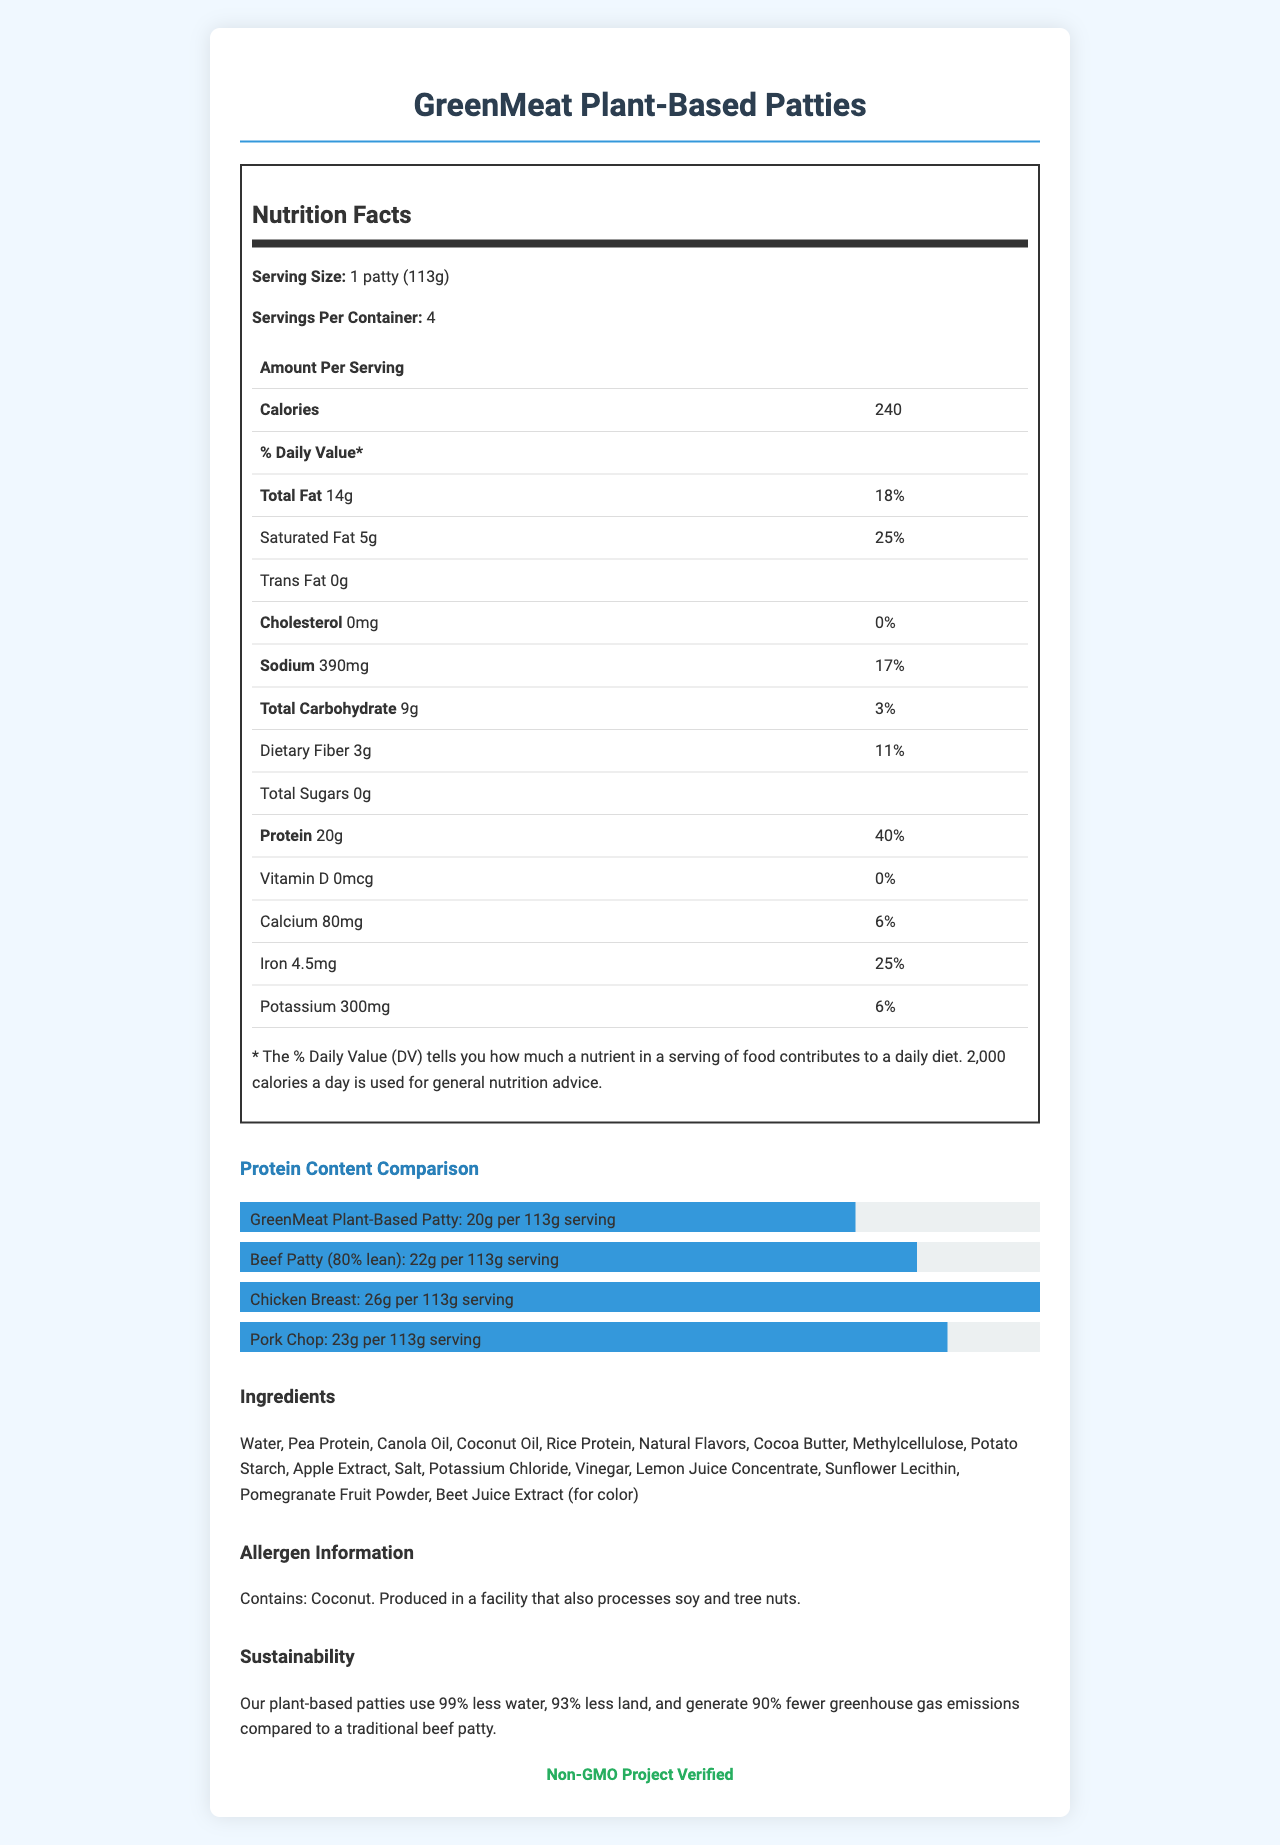what is the protein content of the GreenMeat Plant-Based Patties? The document lists the protein content for GreenMeat Plant-Based Patties as 20g per 113g serving.
Answer: 20g per 113g serving How many calories are in one serving of GreenMeat Plant-Based Patties? The document specifies that one serving (1 patty, 113g) contains 240 calories.
Answer: 240 calories what is the sodium content in one serving? The document states that the sodium content in one serving is 390 mg.
Answer: 390 mg How much saturated fat is in a serving of GreenMeat Plant-Based Patties? The saturated fat content per serving is listed as 5g in the document.
Answer: 5g what are the main ingredients of the GreenMeat Plant-Based Patties? The ingredients listed for the product include Water, Pea Protein, Canola Oil, Coconut Oil, and other ingredients.
Answer: Water, Pea Protein, Canola Oil, Coconut Oil, etc. Which of these has the highest protein content? A. GreenMeat Plant-Based Patties B. Beef Patty (80% lean) C. Chicken Breast D. Pork Chop The document states that Chicken Breast has the highest protein content at 26g per 113g serving.
Answer: C What is the daily value percentage of dietary fiber in GreenMeat Plant-Based Patties? A. 3% B. 11% C. 6% D. 25% The document lists the daily value percentage of dietary fiber as 11%.
Answer: B Do the GreenMeat Plant-Based Patties contain cholesterol? The document indicates that the cholesterol content is 0 mg, meaning there is no cholesterol.
Answer: No How should the GreenMeat Plant-Based Patties be stored? The storage instructions provided in the document are to keep the patties refrigerated or frozen and thaw in the refrigerator before cooking.
Answer: Keep refrigerated or frozen. Thaw in refrigerator before cooking. Is the GreenMeat Plant-Based product associated with any sustainability claims? The document mentions that the product claims to use 99% less water, 93% less land, and generate 90% fewer greenhouse gas emissions compared to a traditional beef patty.
Answer: Yes Summarize the main features and information provided in the document. This summary captures the essential elements and highlights of the data presented in the document, giving an overview of nutritional content, ingredient details, sustainability claims, and contractual specifics.
Answer: The document provides detailed information about the GreenMeat Plant-Based Patties, including nutrition facts (such as calories, fat, cholesterol, protein, vitamins, and minerals), a comparison of protein content with traditional meat sources, ingredients, allergen information, storage and cooking instructions, sustainability claims, and certifications. It also highlights exclusive distribution rights, minimum order quantities, payment terms, and marketing budgets from contract highlights. what is the percentage of daily value for potassium in a serving? The document states the daily value percentage for potassium as 6%.
Answer: 6% can I find the exact price of the product in the document? The document does not provide any information about the price of the product.
Answer: Not enough information What certification does the GreenMeat Plant-Based product hold? The document mentions that the product is Non-GMO Project Verified.
Answer: Non-GMO Project Verified 